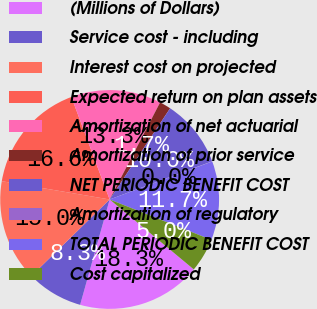<chart> <loc_0><loc_0><loc_500><loc_500><pie_chart><fcel>(Millions of Dollars)<fcel>Service cost - including<fcel>Interest cost on projected<fcel>Expected return on plan assets<fcel>Amortization of net actuarial<fcel>Amortization of prior service<fcel>NET PERIODIC BENEFIT COST<fcel>Amortization of regulatory<fcel>TOTAL PERIODIC BENEFIT COST<fcel>Cost capitalized<nl><fcel>18.31%<fcel>8.34%<fcel>14.98%<fcel>16.64%<fcel>13.32%<fcel>1.69%<fcel>10.0%<fcel>0.03%<fcel>11.66%<fcel>5.02%<nl></chart> 